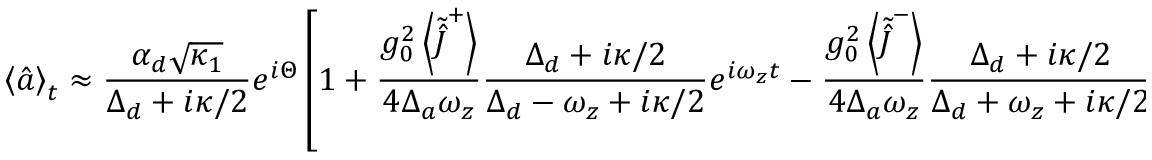<formula> <loc_0><loc_0><loc_500><loc_500>\left \langle \hat { a } \right \rangle _ { t } \approx \frac { \alpha _ { d } \sqrt { \kappa _ { 1 } } } { \Delta _ { d } + i \kappa / 2 } e ^ { i \Theta } \left [ 1 + \frac { g _ { 0 } ^ { 2 } \left \langle \tilde { \hat { J } } ^ { + } \right \rangle } { 4 \Delta _ { a } \omega _ { z } } \frac { \Delta _ { d } + i \kappa / 2 } { \Delta _ { d } - \omega _ { z } + i \kappa / 2 } e ^ { i \omega _ { z } t } - \frac { g _ { 0 } ^ { 2 } \left \langle \tilde { \hat { J } } ^ { - } \right \rangle } { 4 \Delta _ { a } \omega _ { z } } \frac { \Delta _ { d } + i \kappa / 2 } { \Delta _ { d } + \omega _ { z } + i \kappa / 2 } e ^ { - i \omega _ { z } t } \right ] .</formula> 